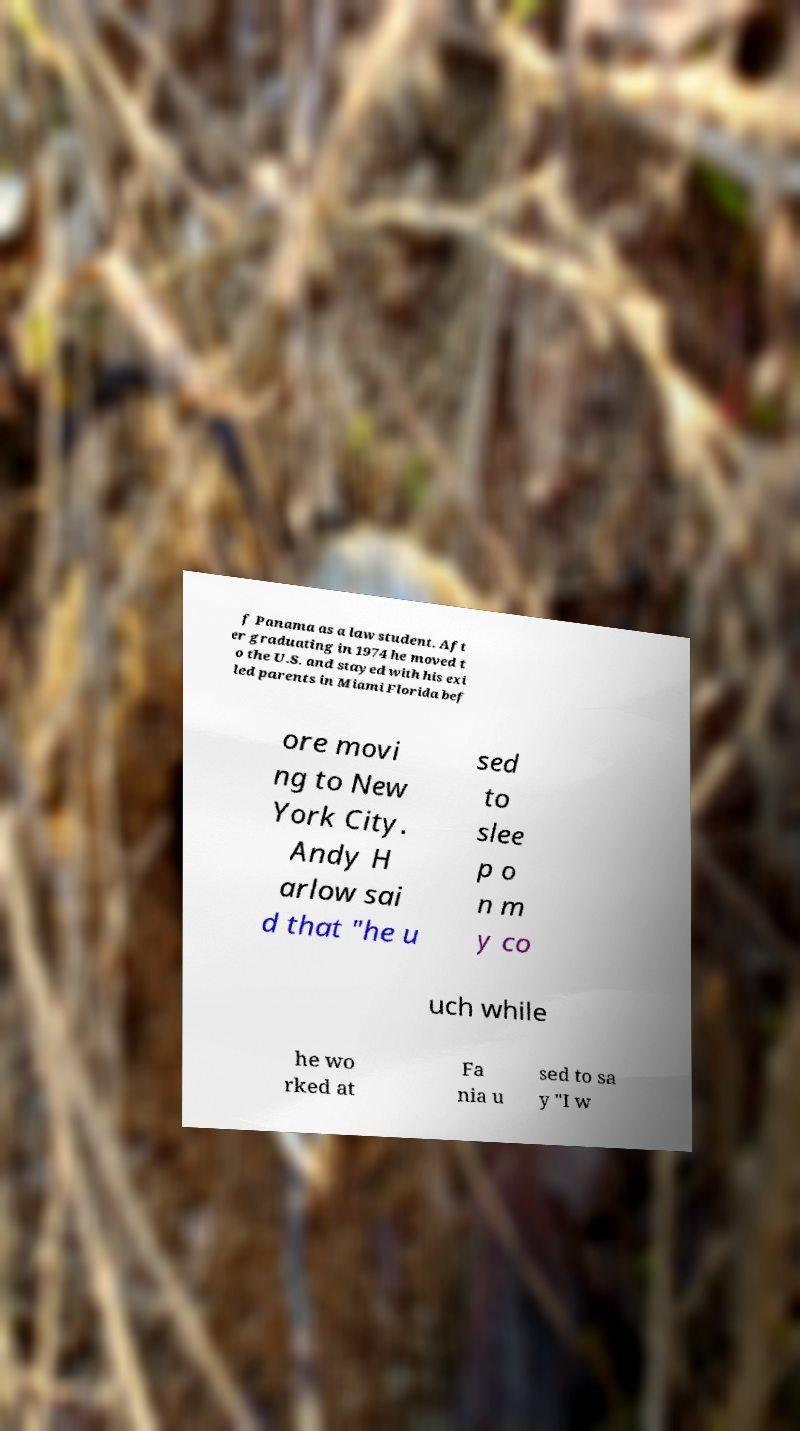Could you extract and type out the text from this image? f Panama as a law student. Aft er graduating in 1974 he moved t o the U.S. and stayed with his exi led parents in Miami Florida bef ore movi ng to New York City. Andy H arlow sai d that "he u sed to slee p o n m y co uch while he wo rked at Fa nia u sed to sa y "I w 